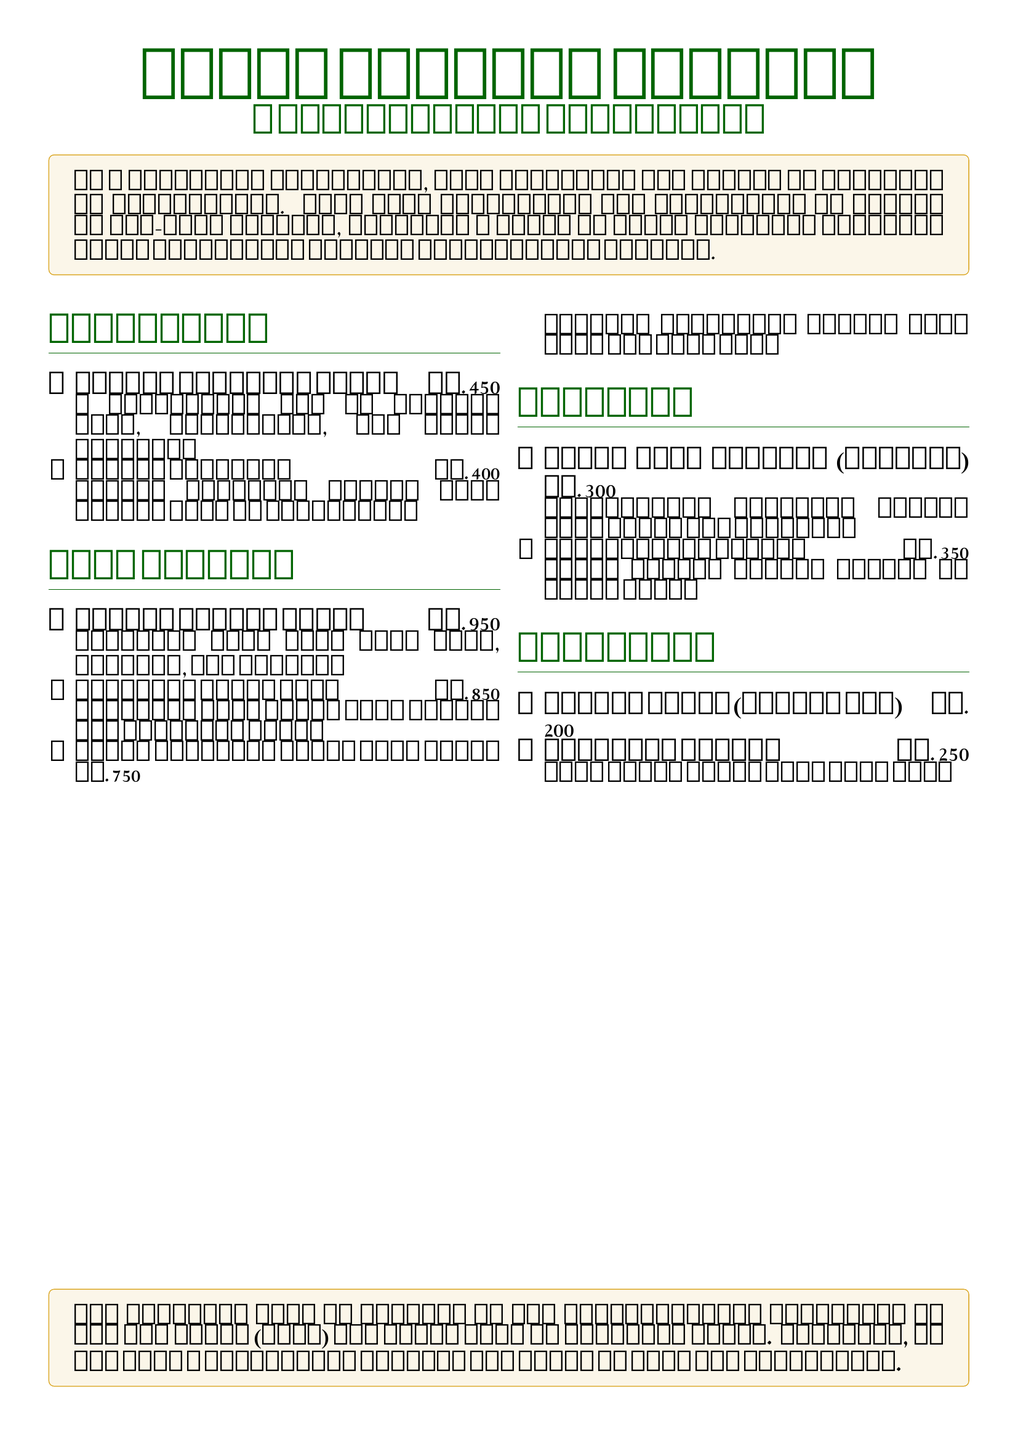What is the name of the fundraiser? The fundraiser is titled "Peace Through Cuisine."
Answer: Peace Through Cuisine What organization will benefit from the proceeds? The proceeds will be donated to the International Committee of the Red Cross (ICRC).
Answer: International Committee of the Red Cross (ICRC) How much does the Afghan Qabuli Pulao cost? The price of Afghan Qabuli Pulao is mentioned as Rs. 950.
Answer: Rs. 950 Which dish is filled with dates and cardamom? The Iraqi Date Cookies (Kleicha) are filled with dates and cardamom.
Answer: Iraqi Date Cookies (Kleicha) What type of drink is Somali Shaah? Somali Shaah is described as spiced tea.
Answer: Spiced Tea How many appetizers are listed in the menu? There are two appetizers listed in the menu.
Answer: 2 What cuisine does the Palestinian Knafeh belong to? The Palestinian Knafeh is part of Palestinian cuisine.
Answer: Palestinian What is a key ingredient in the Yemeni Sambousa? Yemeni Sambousa is filled with spiced meat or vegetables.
Answer: Spiced meat or vegetables What type of flatbread is served with South Sudanese Kisra? Sorghum flatbread is served with South Sudanese Kisra.
Answer: Sorghum flatbread 